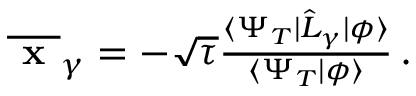<formula> <loc_0><loc_0><loc_500><loc_500>\begin{array} { r } { \overline { x } _ { \gamma } = - \sqrt { \tau } \frac { \langle \Psi _ { T } | \hat { L } _ { \gamma } | \phi \rangle } { \langle \Psi _ { T } | \phi \rangle } \, . } \end{array}</formula> 